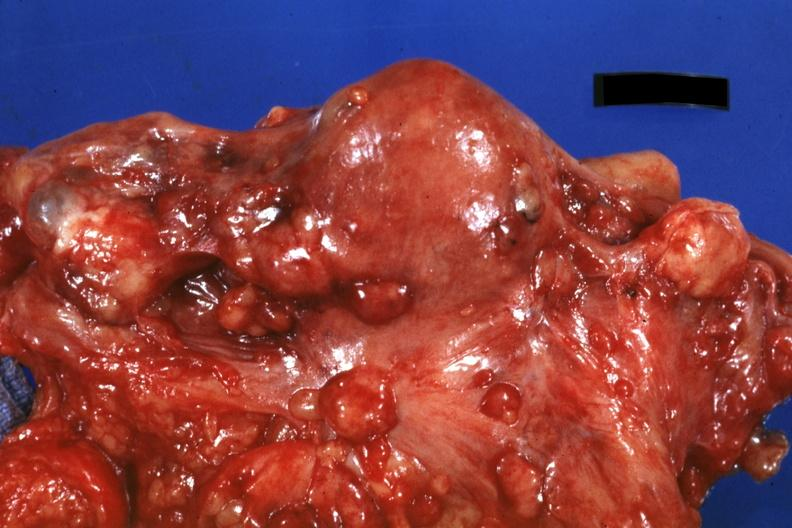does this image show close-up of uterus and ovaries with metastatic carcinoma on peritoneal surface?
Answer the question using a single word or phrase. Yes 